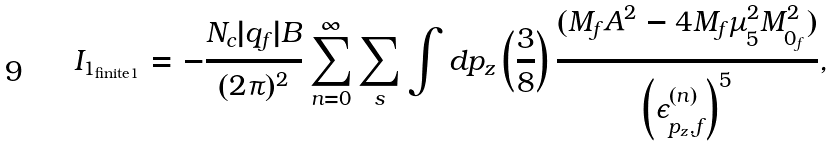<formula> <loc_0><loc_0><loc_500><loc_500>I _ { 1 _ { \text {finite1} } } = - \frac { N _ { c } | q _ { f } | B } { ( 2 \pi ) ^ { 2 } } \sum _ { n = 0 } ^ { \infty } \sum _ { s } \int d p _ { z } \left ( \frac { 3 } { 8 } \right ) \frac { ( M _ { f } A ^ { 2 } - 4 M _ { f } \mu _ { 5 } ^ { 2 } M _ { 0 _ { f } } ^ { 2 } ) } { \left ( \epsilon ^ { ( n ) } _ { p _ { z } , f } \right ) ^ { 5 } } ,</formula> 